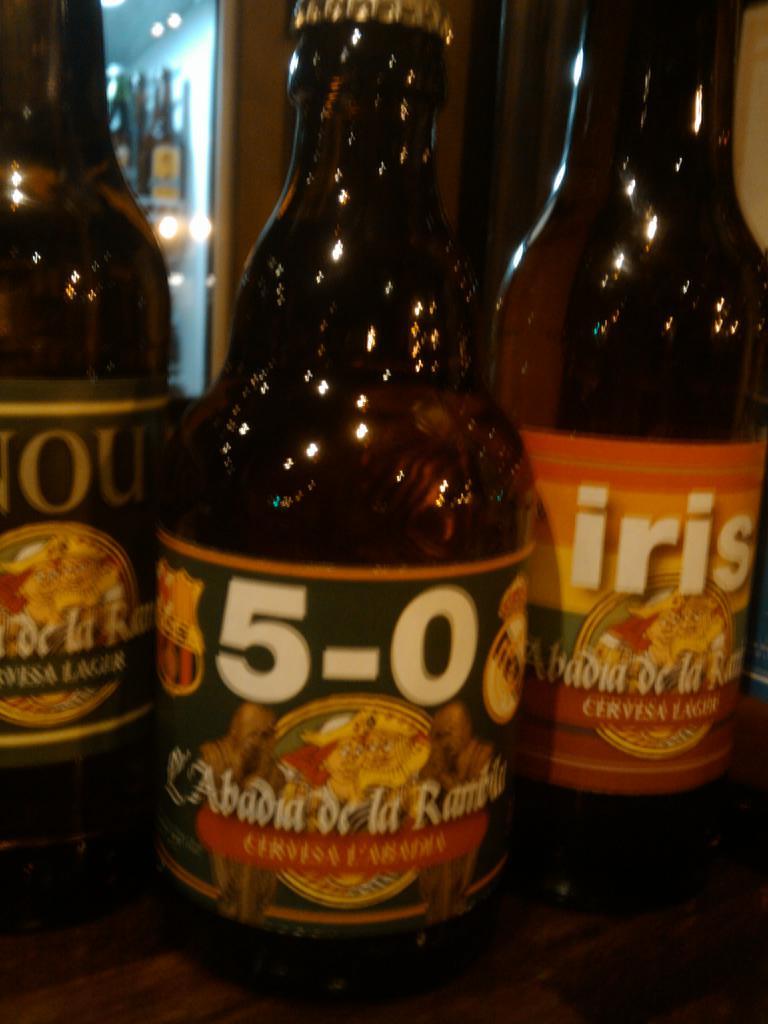What is the name of the bottle on the right?
Offer a terse response. Iris. 